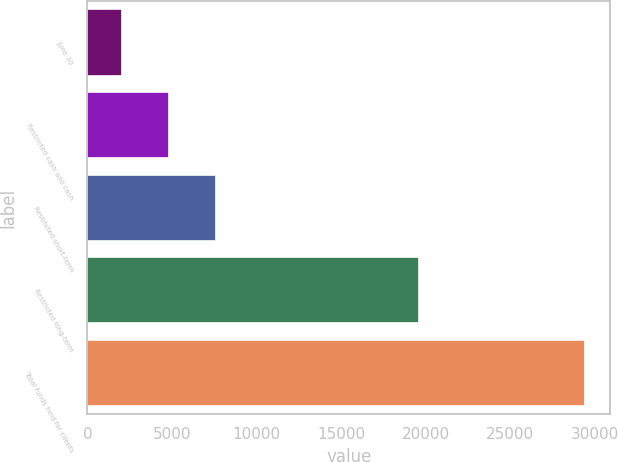Convert chart to OTSL. <chart><loc_0><loc_0><loc_500><loc_500><bar_chart><fcel>June 30<fcel>Restricted cash and cash<fcel>Restricted short-term<fcel>Restricted long-term<fcel>Total funds held for clients<nl><fcel>2019<fcel>4847<fcel>7588.52<fcel>19573.3<fcel>29434.2<nl></chart> 